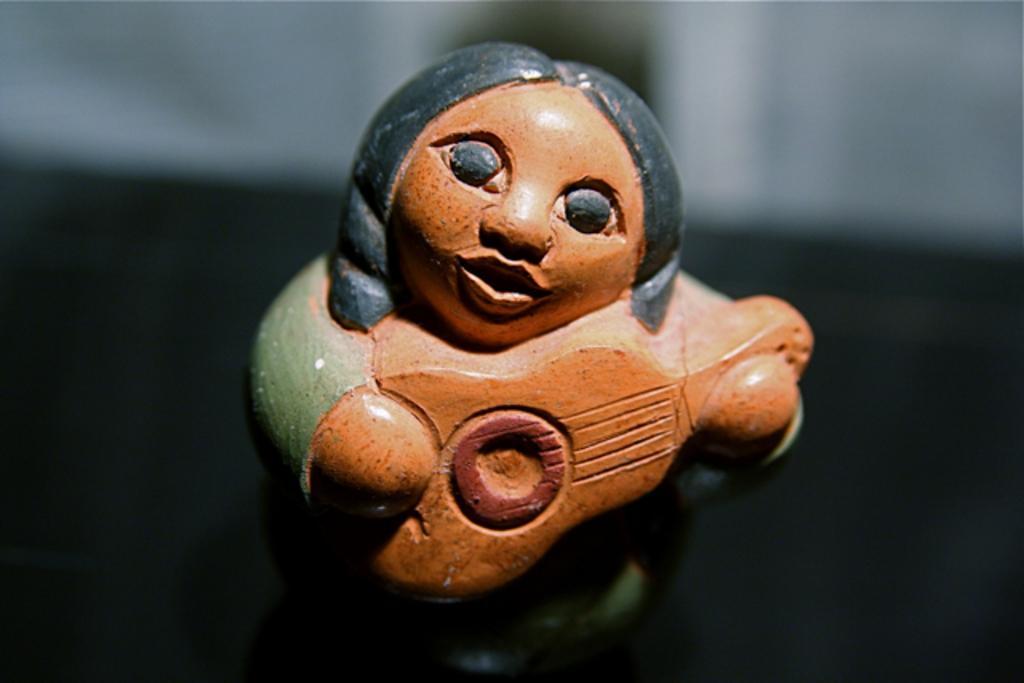How would you summarize this image in a sentence or two? In this image I can see a mini sculpture in the front. I can see colour of this sculpture is brown, green and black. I can also see this image is little bit blurry in the background. 